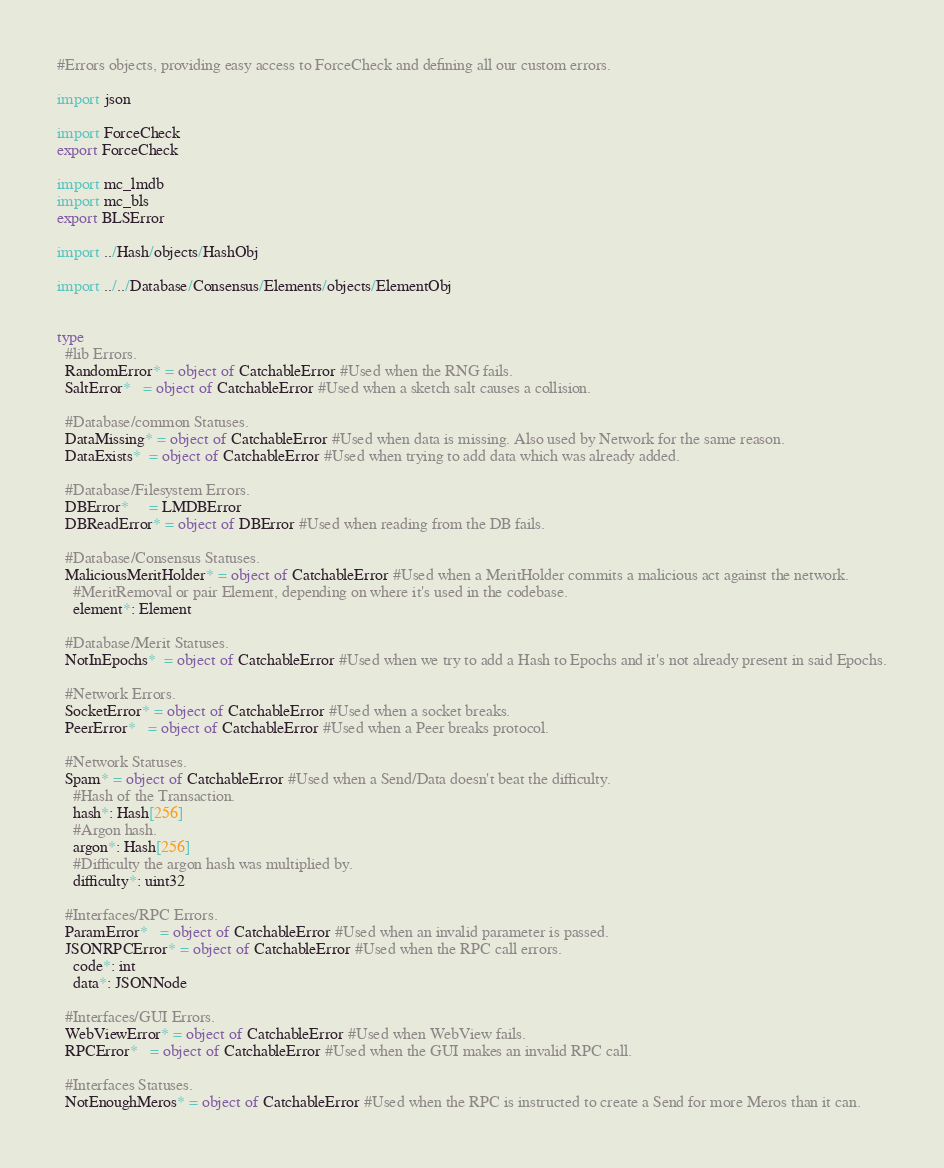Convert code to text. <code><loc_0><loc_0><loc_500><loc_500><_Nim_>#Errors objects, providing easy access to ForceCheck and defining all our custom errors.

import json

import ForceCheck
export ForceCheck

import mc_lmdb
import mc_bls
export BLSError

import ../Hash/objects/HashObj

import ../../Database/Consensus/Elements/objects/ElementObj


type
  #lib Errors.
  RandomError* = object of CatchableError #Used when the RNG fails.
  SaltError*   = object of CatchableError #Used when a sketch salt causes a collision.

  #Database/common Statuses.
  DataMissing* = object of CatchableError #Used when data is missing. Also used by Network for the same reason.
  DataExists*  = object of CatchableError #Used when trying to add data which was already added.

  #Database/Filesystem Errors.
  DBError*     = LMDBError
  DBReadError* = object of DBError #Used when reading from the DB fails.

  #Database/Consensus Statuses.
  MaliciousMeritHolder* = object of CatchableError #Used when a MeritHolder commits a malicious act against the network.
    #MeritRemoval or pair Element, depending on where it's used in the codebase.
    element*: Element

  #Database/Merit Statuses.
  NotInEpochs*  = object of CatchableError #Used when we try to add a Hash to Epochs and it's not already present in said Epochs.

  #Network Errors.
  SocketError* = object of CatchableError #Used when a socket breaks.
  PeerError*   = object of CatchableError #Used when a Peer breaks protocol.

  #Network Statuses.
  Spam* = object of CatchableError #Used when a Send/Data doesn't beat the difficulty.
    #Hash of the Transaction.
    hash*: Hash[256]
    #Argon hash.
    argon*: Hash[256]
    #Difficulty the argon hash was multiplied by.
    difficulty*: uint32

  #Interfaces/RPC Errors.
  ParamError*   = object of CatchableError #Used when an invalid parameter is passed.
  JSONRPCError* = object of CatchableError #Used when the RPC call errors.
    code*: int
    data*: JSONNode

  #Interfaces/GUI Errors.
  WebViewError* = object of CatchableError #Used when WebView fails.
  RPCError*   = object of CatchableError #Used when the GUI makes an invalid RPC call.

  #Interfaces Statuses.
  NotEnoughMeros* = object of CatchableError #Used when the RPC is instructed to create a Send for more Meros than it can.
</code> 